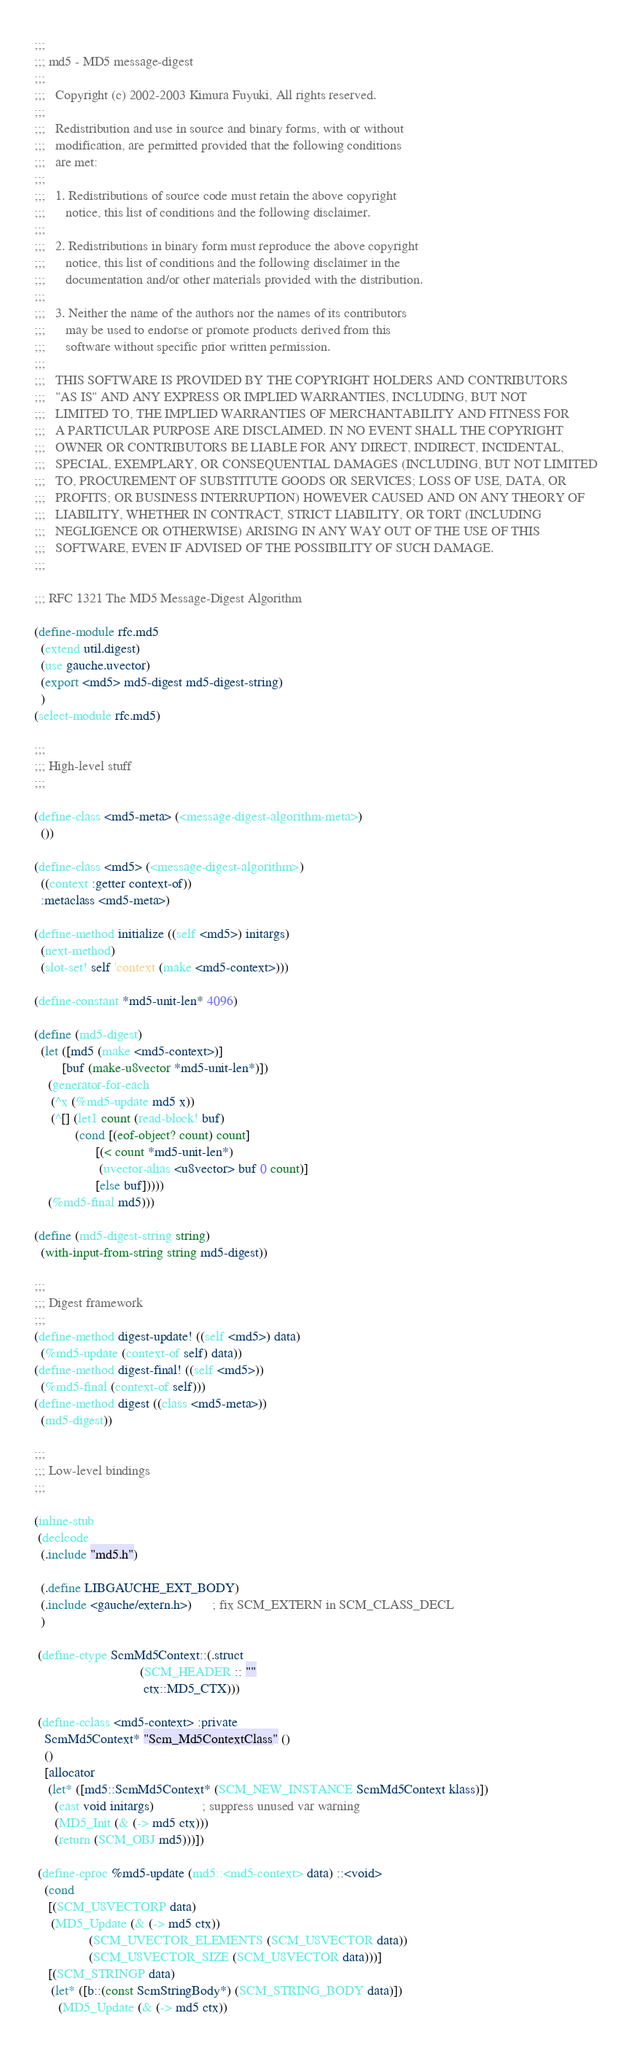<code> <loc_0><loc_0><loc_500><loc_500><_Scheme_>;;;
;;; md5 - MD5 message-digest
;;;
;;;   Copyright (c) 2002-2003 Kimura Fuyuki, All rights reserved.
;;;
;;;   Redistribution and use in source and binary forms, with or without
;;;   modification, are permitted provided that the following conditions
;;;   are met:
;;;
;;;   1. Redistributions of source code must retain the above copyright
;;;      notice, this list of conditions and the following disclaimer.
;;;
;;;   2. Redistributions in binary form must reproduce the above copyright
;;;      notice, this list of conditions and the following disclaimer in the
;;;      documentation and/or other materials provided with the distribution.
;;;
;;;   3. Neither the name of the authors nor the names of its contributors
;;;      may be used to endorse or promote products derived from this
;;;      software without specific prior written permission.
;;;
;;;   THIS SOFTWARE IS PROVIDED BY THE COPYRIGHT HOLDERS AND CONTRIBUTORS
;;;   "AS IS" AND ANY EXPRESS OR IMPLIED WARRANTIES, INCLUDING, BUT NOT
;;;   LIMITED TO, THE IMPLIED WARRANTIES OF MERCHANTABILITY AND FITNESS FOR
;;;   A PARTICULAR PURPOSE ARE DISCLAIMED. IN NO EVENT SHALL THE COPYRIGHT
;;;   OWNER OR CONTRIBUTORS BE LIABLE FOR ANY DIRECT, INDIRECT, INCIDENTAL,
;;;   SPECIAL, EXEMPLARY, OR CONSEQUENTIAL DAMAGES (INCLUDING, BUT NOT LIMITED
;;;   TO, PROCUREMENT OF SUBSTITUTE GOODS OR SERVICES; LOSS OF USE, DATA, OR
;;;   PROFITS; OR BUSINESS INTERRUPTION) HOWEVER CAUSED AND ON ANY THEORY OF
;;;   LIABILITY, WHETHER IN CONTRACT, STRICT LIABILITY, OR TORT (INCLUDING
;;;   NEGLIGENCE OR OTHERWISE) ARISING IN ANY WAY OUT OF THE USE OF THIS
;;;   SOFTWARE, EVEN IF ADVISED OF THE POSSIBILITY OF SUCH DAMAGE.
;;;

;;; RFC 1321 The MD5 Message-Digest Algorithm

(define-module rfc.md5
  (extend util.digest)
  (use gauche.uvector)
  (export <md5> md5-digest md5-digest-string)
  )
(select-module rfc.md5)

;;;
;;; High-level stuff
;;;

(define-class <md5-meta> (<message-digest-algorithm-meta>)
  ())

(define-class <md5> (<message-digest-algorithm>)
  ((context :getter context-of))
  :metaclass <md5-meta>)

(define-method initialize ((self <md5>) initargs)
  (next-method)
  (slot-set! self 'context (make <md5-context>)))

(define-constant *md5-unit-len* 4096)

(define (md5-digest)
  (let ([md5 (make <md5-context>)]
        [buf (make-u8vector *md5-unit-len*)])
    (generator-for-each
     (^x (%md5-update md5 x))
     (^[] (let1 count (read-block! buf)
            (cond [(eof-object? count) count]
                  [(< count *md5-unit-len*)
                   (uvector-alias <u8vector> buf 0 count)]
                  [else buf]))))
    (%md5-final md5)))

(define (md5-digest-string string)
  (with-input-from-string string md5-digest))

;;;
;;; Digest framework
;;;
(define-method digest-update! ((self <md5>) data)
  (%md5-update (context-of self) data))
(define-method digest-final! ((self <md5>))
  (%md5-final (context-of self)))
(define-method digest ((class <md5-meta>))
  (md5-digest))

;;;
;;; Low-level bindings
;;;

(inline-stub
 (declcode
  (.include "md5.h")

  (.define LIBGAUCHE_EXT_BODY)
  (.include <gauche/extern.h>)      ; fix SCM_EXTERN in SCM_CLASS_DECL
  )

 (define-ctype ScmMd5Context::(.struct
                               (SCM_HEADER :: ""
                                ctx::MD5_CTX)))

 (define-cclass <md5-context> :private
   ScmMd5Context* "Scm_Md5ContextClass" ()
   ()
   [allocator
    (let* ([md5::ScmMd5Context* (SCM_NEW_INSTANCE ScmMd5Context klass)])
      (cast void initargs)              ; suppress unused var warning
      (MD5_Init (& (-> md5 ctx)))
      (return (SCM_OBJ md5)))])

 (define-cproc %md5-update (md5::<md5-context> data) ::<void>
   (cond
    [(SCM_U8VECTORP data)
     (MD5_Update (& (-> md5 ctx))
                (SCM_UVECTOR_ELEMENTS (SCM_U8VECTOR data))
                (SCM_U8VECTOR_SIZE (SCM_U8VECTOR data)))]
    [(SCM_STRINGP data)
     (let* ([b::(const ScmStringBody*) (SCM_STRING_BODY data)])
       (MD5_Update (& (-> md5 ctx))</code> 